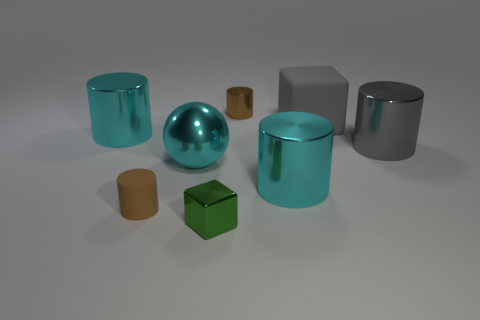There is a tiny metal thing that is the same shape as the large rubber thing; what color is it?
Provide a short and direct response. Green. There is a tiny object that is the same color as the tiny matte cylinder; what is its material?
Make the answer very short. Metal. What is the color of the small shiny thing that is on the left side of the brown metal thing?
Give a very brief answer. Green. Is the ball the same color as the tiny metallic cube?
Provide a succinct answer. No. There is a tiny brown thing that is on the left side of the tiny thing that is on the right side of the green metal object; what number of green things are on the left side of it?
Offer a terse response. 0. What size is the brown matte object?
Your response must be concise. Small. There is a cyan ball that is the same size as the gray rubber block; what material is it?
Offer a terse response. Metal. There is a green cube; what number of large cylinders are in front of it?
Your response must be concise. 0. Is the material of the tiny brown cylinder that is on the left side of the small green metal block the same as the brown cylinder behind the small matte thing?
Ensure brevity in your answer.  No. What is the shape of the thing that is right of the block right of the cyan metal thing that is right of the metal cube?
Keep it short and to the point. Cylinder. 